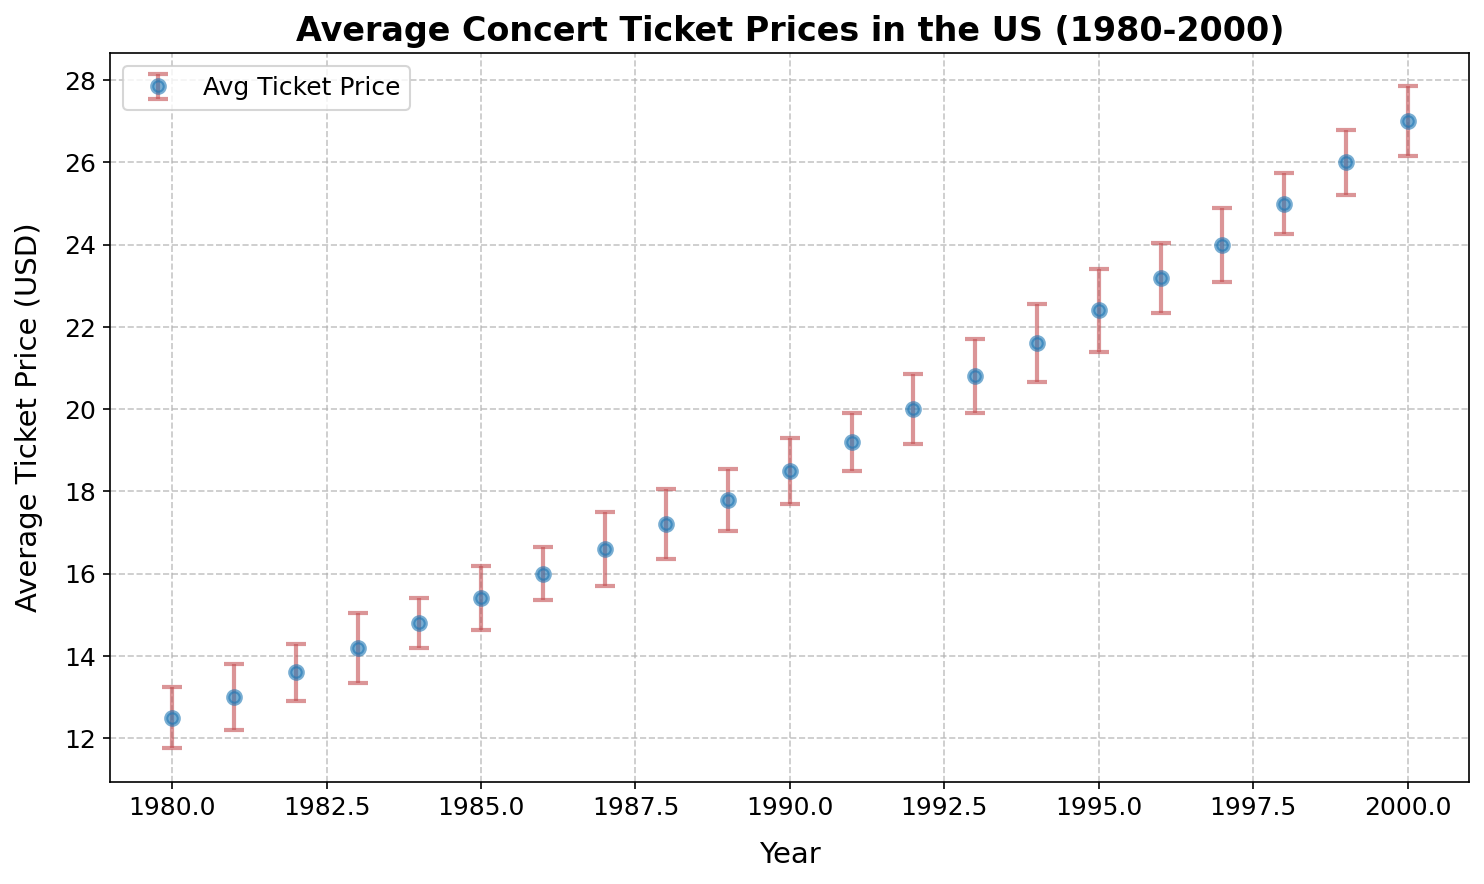What is the average concert ticket price in 1992? Look at the plotted data points and read the value for the year 1992. According to the figure, the average concert ticket price in 1992 is $20.00.
Answer: $20.00 Which year had the highest average concert ticket price? Observe the plotted data points and identify the maximum ticket price. The year 2000 has the highest average concert ticket price of $27.00.
Answer: 2000 Between which consecutive years did the average concert ticket price increase the most? Calculate the difference in average ticket prices for each consecutive year and find the largest increase. The increase from 1999 to 2000 is $1.00, the highest among all intervals.
Answer: 1999 to 2000 What is the difference in average concert ticket prices between 1980 and 2000? Subtract the average ticket price in 1980 from the average ticket price in 2000. The difference is $27.00 − $12.50 = $14.50.
Answer: $14.50 What is the lowest variance in average concert ticket prices, and in which year did it occur? Identify the data point with the smallest error bar, indicating the smallest variance. The lowest variance is 0.60 in 1984.
Answer: 1984, 0.60 How does the variance in 1995 compare to the variance in 1985? Compare the size of the error bars for the years 1995 and 1985. The variance in 1995 is 1.00, and in 1985, it is 0.78. Hence, the variance in 1995 is greater than that in 1985.
Answer: Greater Which year had the most stability in average concert ticket prices? The most stable year is characterized by the smallest variance, as indicated by the shortest error bar. The year 1984 with a variance of 0.60 had the most stability.
Answer: 1984 What is the trend of average concert ticket prices from 1980 to 2000? Observe the overall direction of the plotted data points. The average concert ticket prices steadily increased from 1980 to 2000.
Answer: Increasing What is the difference in average ticket prices between 1990 and 2000, and how does this compare to the difference between 1980 and 1990? Subtract the 1990 price from the 2000 price ($27.00 − $18.50) to get $8.50. Now subtract the 1980 price from the 1990 price ($18.50 − $12.50) to get $6.00. Comparing these, the increase between 1990 and 2000 ($8.50) is greater than the increase between 1980 and 1990 ($6.00).
Answer: $8.50, $6.00, greater 